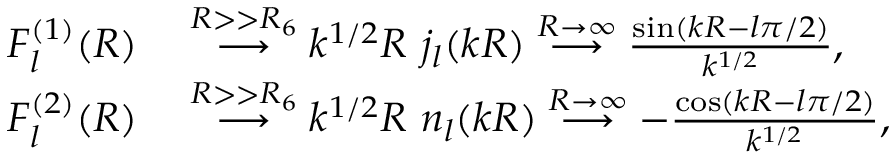<formula> <loc_0><loc_0><loc_500><loc_500>\begin{array} { r l } { F _ { l } ^ { ( 1 ) } ( R ) } & \stackrel { R > > R _ { 6 } } { \longrightarrow } k ^ { 1 / 2 } R \, j _ { l } ( k R ) \stackrel { R \to \infty } { \longrightarrow } \frac { \sin ( k R - l \pi / 2 ) } { k ^ { 1 / 2 } } , } \\ { F _ { l } ^ { ( 2 ) } ( R ) } & \stackrel { R > > R _ { 6 } } { \longrightarrow } k ^ { 1 / 2 } R \, n _ { l } ( k R ) \stackrel { R \to \infty } { \longrightarrow } - \frac { \cos ( k R - l \pi / 2 ) } { k ^ { 1 / 2 } } , } \end{array}</formula> 